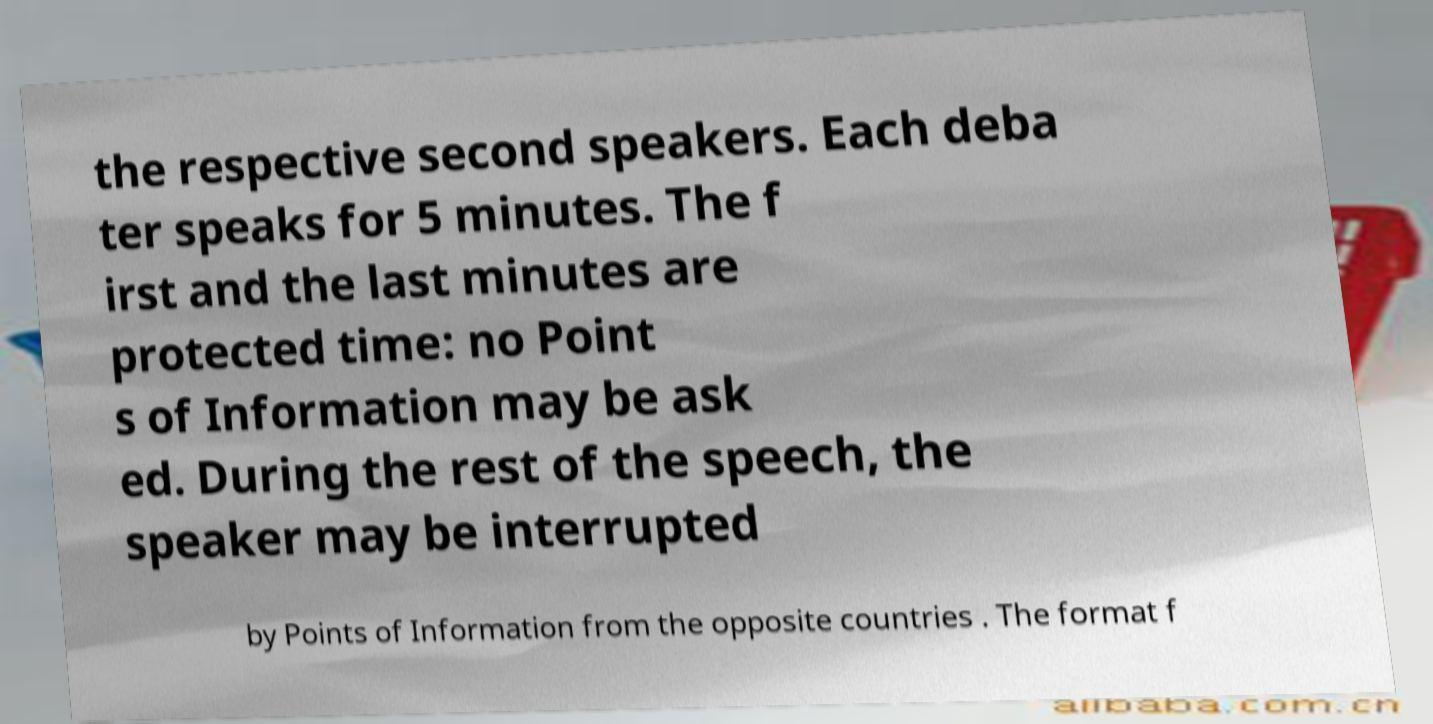Please identify and transcribe the text found in this image. the respective second speakers. Each deba ter speaks for 5 minutes. The f irst and the last minutes are protected time: no Point s of Information may be ask ed. During the rest of the speech, the speaker may be interrupted by Points of Information from the opposite countries . The format f 